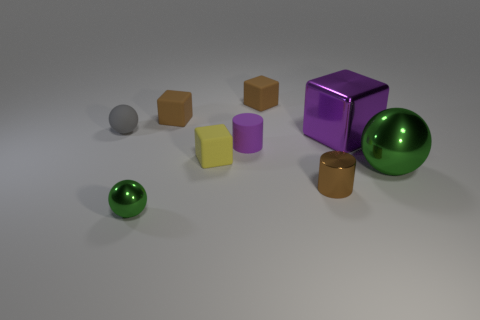Add 1 big metallic blocks. How many objects exist? 10 Subtract all blue blocks. Subtract all brown balls. How many blocks are left? 4 Subtract all blocks. How many objects are left? 5 Subtract all yellow matte cubes. Subtract all big purple objects. How many objects are left? 7 Add 1 large purple cubes. How many large purple cubes are left? 2 Add 2 tiny blocks. How many tiny blocks exist? 5 Subtract 0 yellow cylinders. How many objects are left? 9 